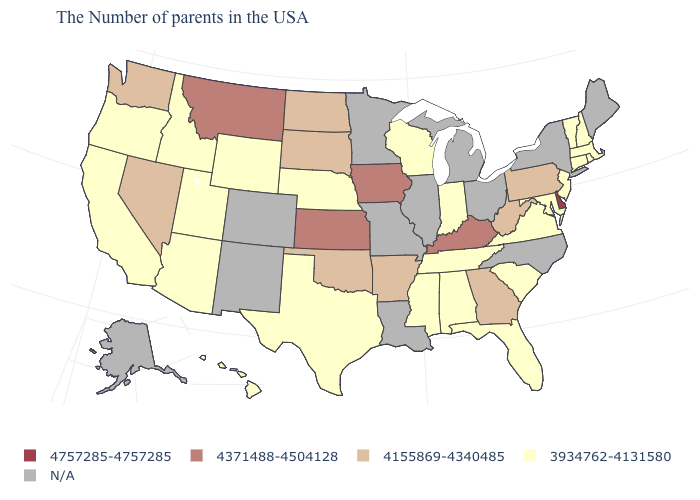Among the states that border North Carolina , does Virginia have the lowest value?
Write a very short answer. Yes. What is the value of Ohio?
Short answer required. N/A. What is the value of North Carolina?
Be succinct. N/A. Among the states that border Iowa , which have the lowest value?
Concise answer only. Wisconsin, Nebraska. How many symbols are there in the legend?
Write a very short answer. 5. Name the states that have a value in the range 4155869-4340485?
Give a very brief answer. Pennsylvania, West Virginia, Georgia, Arkansas, Oklahoma, South Dakota, North Dakota, Nevada, Washington. Does the first symbol in the legend represent the smallest category?
Short answer required. No. Which states hav the highest value in the MidWest?
Be succinct. Iowa, Kansas. What is the highest value in the USA?
Write a very short answer. 4757285-4757285. Does the first symbol in the legend represent the smallest category?
Keep it brief. No. Does Nevada have the highest value in the West?
Answer briefly. No. Does the map have missing data?
Answer briefly. Yes. Among the states that border Idaho , does Utah have the highest value?
Write a very short answer. No. Does Massachusetts have the lowest value in the Northeast?
Write a very short answer. Yes. 